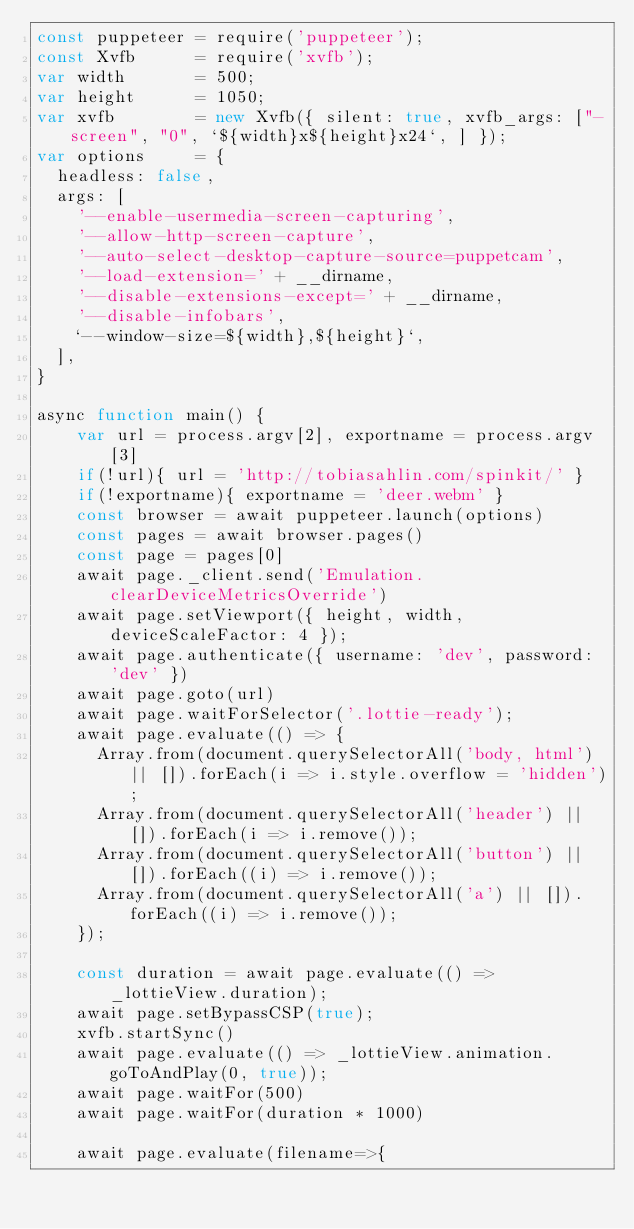<code> <loc_0><loc_0><loc_500><loc_500><_JavaScript_>const puppeteer = require('puppeteer');
const Xvfb      = require('xvfb');
var width       = 500;
var height      = 1050;
var xvfb        = new Xvfb({ silent: true, xvfb_args: ["-screen", "0", `${width}x${height}x24`, ] });
var options     = {
  headless: false,
  args: [
    '--enable-usermedia-screen-capturing',
    '--allow-http-screen-capture',
    '--auto-select-desktop-capture-source=puppetcam',
    '--load-extension=' + __dirname,
    '--disable-extensions-except=' + __dirname,
    '--disable-infobars',
    `--window-size=${width},${height}`,
  ],
}

async function main() {
    var url = process.argv[2], exportname = process.argv[3]
    if(!url){ url = 'http://tobiasahlin.com/spinkit/' }
    if(!exportname){ exportname = 'deer.webm' }
    const browser = await puppeteer.launch(options)
    const pages = await browser.pages()
    const page = pages[0]
    await page._client.send('Emulation.clearDeviceMetricsOverride')
    await page.setViewport({ height, width, deviceScaleFactor: 4 });
    await page.authenticate({ username: 'dev', password: 'dev' })
    await page.goto(url)
    await page.waitForSelector('.lottie-ready');
    await page.evaluate(() => {
      Array.from(document.querySelectorAll('body, html') || []).forEach(i => i.style.overflow = 'hidden');
      Array.from(document.querySelectorAll('header') || []).forEach(i => i.remove());
      Array.from(document.querySelectorAll('button') || []).forEach((i) => i.remove());
      Array.from(document.querySelectorAll('a') || []).forEach((i) => i.remove());
    });
    
    const duration = await page.evaluate(() => _lottieView.duration);
    await page.setBypassCSP(true);
    xvfb.startSync()
    await page.evaluate(() => _lottieView.animation.goToAndPlay(0, true));
    await page.waitFor(500)
    await page.waitFor(duration * 1000)

    await page.evaluate(filename=>{</code> 